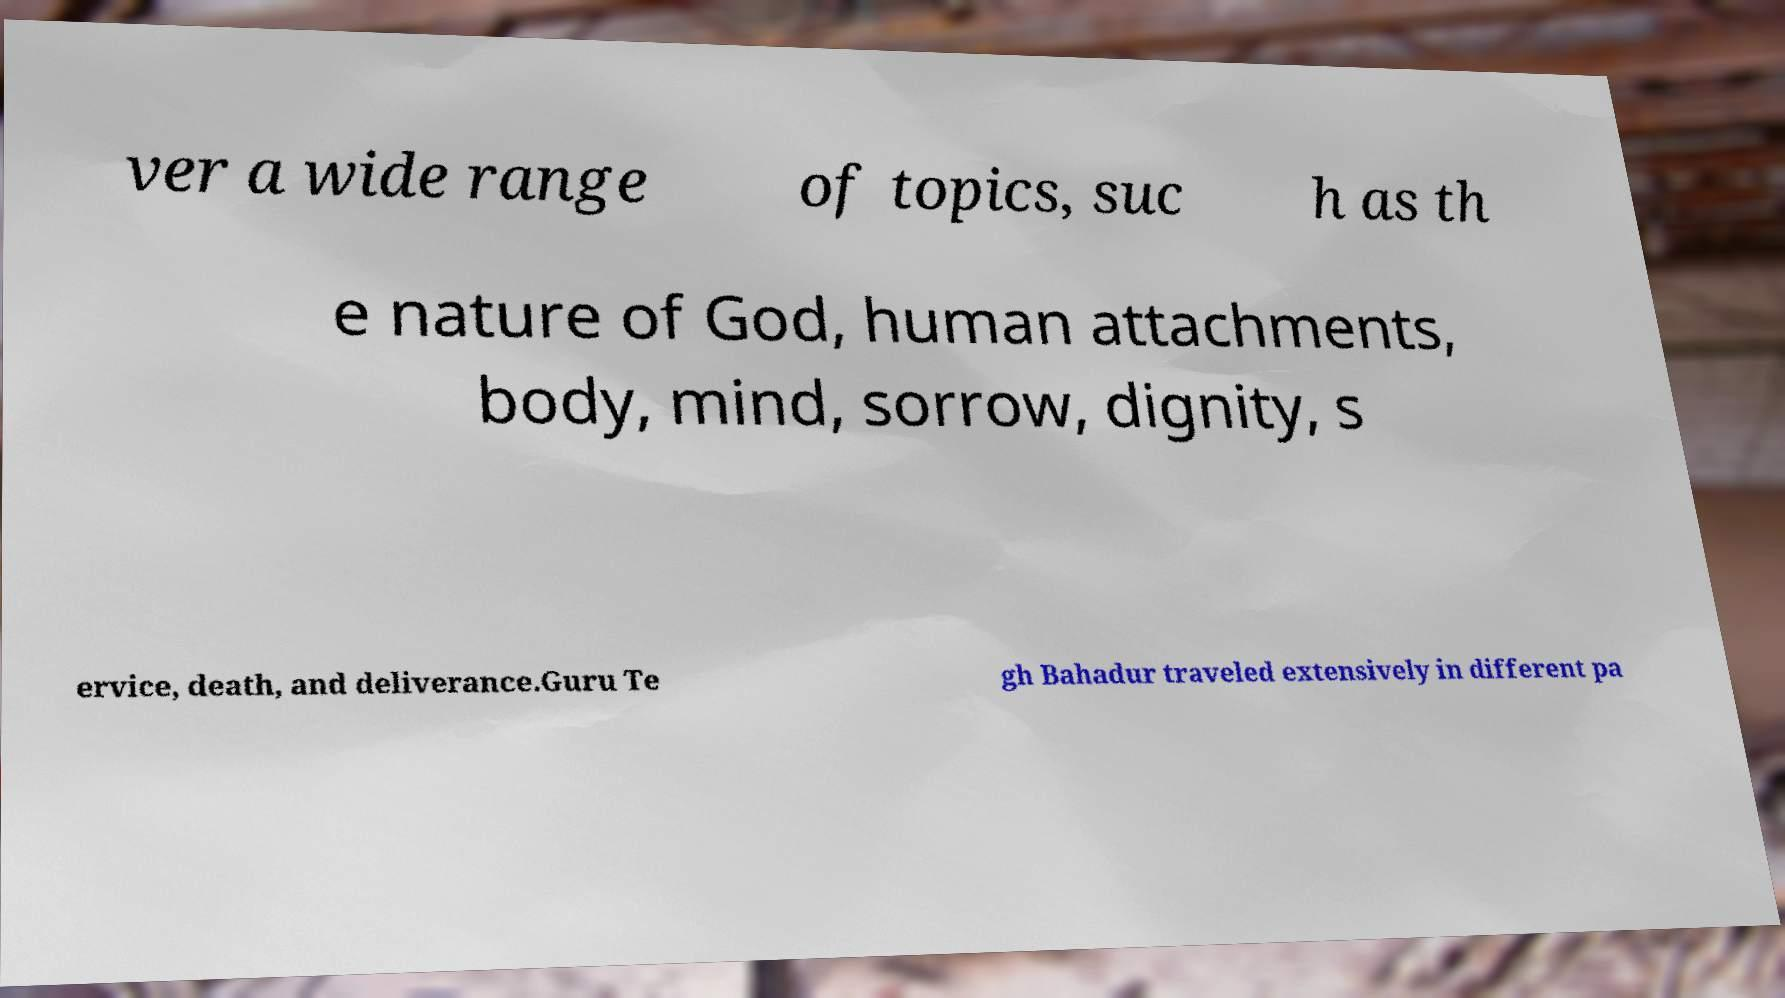Can you read and provide the text displayed in the image?This photo seems to have some interesting text. Can you extract and type it out for me? ver a wide range of topics, suc h as th e nature of God, human attachments, body, mind, sorrow, dignity, s ervice, death, and deliverance.Guru Te gh Bahadur traveled extensively in different pa 